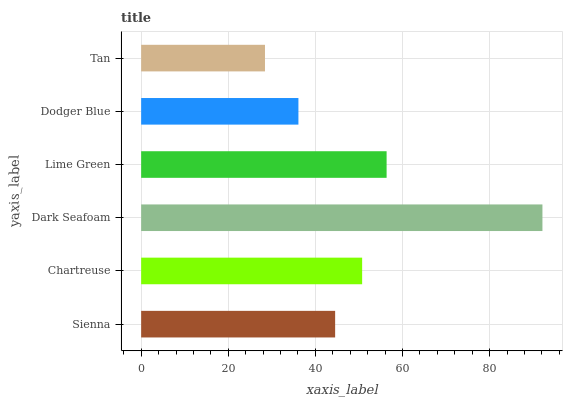Is Tan the minimum?
Answer yes or no. Yes. Is Dark Seafoam the maximum?
Answer yes or no. Yes. Is Chartreuse the minimum?
Answer yes or no. No. Is Chartreuse the maximum?
Answer yes or no. No. Is Chartreuse greater than Sienna?
Answer yes or no. Yes. Is Sienna less than Chartreuse?
Answer yes or no. Yes. Is Sienna greater than Chartreuse?
Answer yes or no. No. Is Chartreuse less than Sienna?
Answer yes or no. No. Is Chartreuse the high median?
Answer yes or no. Yes. Is Sienna the low median?
Answer yes or no. Yes. Is Tan the high median?
Answer yes or no. No. Is Lime Green the low median?
Answer yes or no. No. 